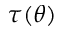<formula> <loc_0><loc_0><loc_500><loc_500>\tau ( \theta )</formula> 